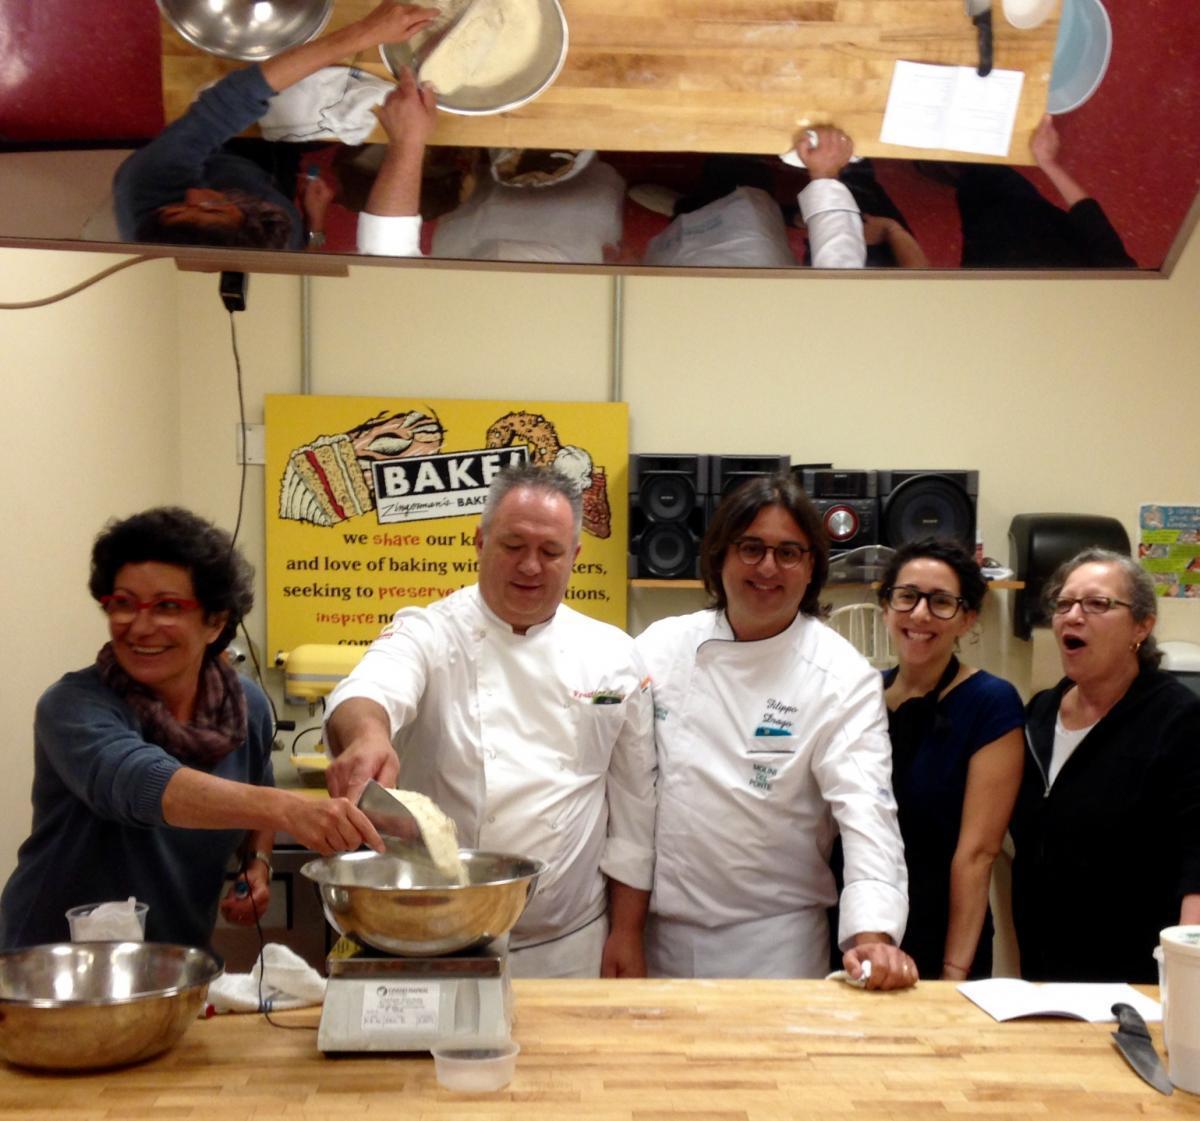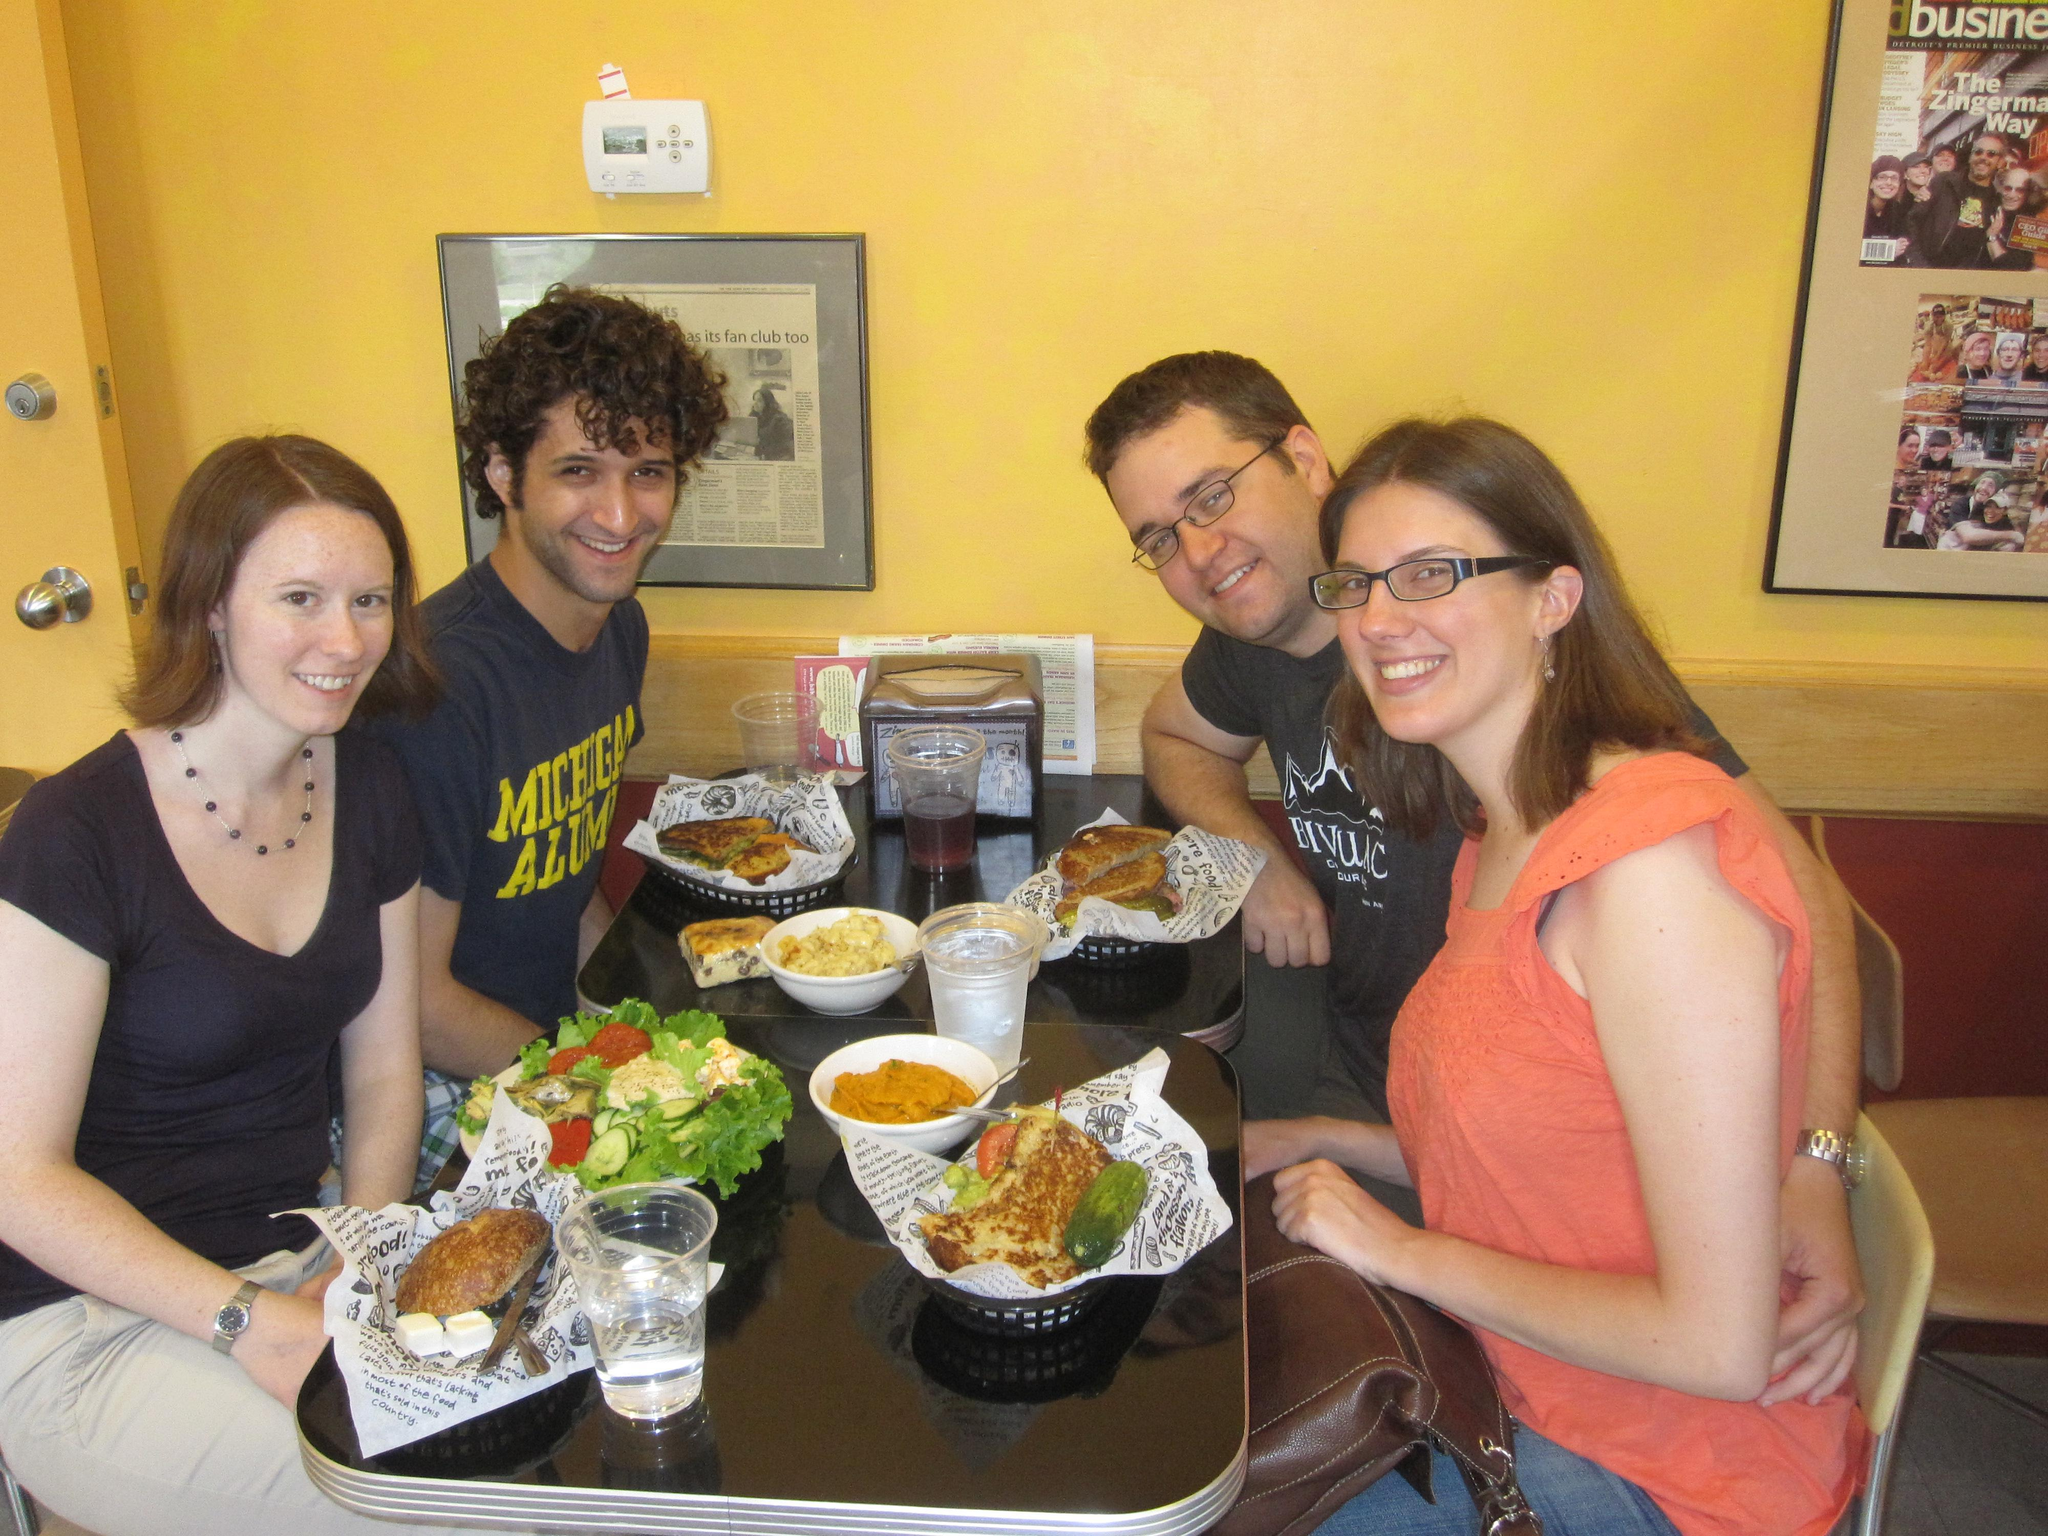The first image is the image on the left, the second image is the image on the right. Considering the images on both sides, is "There are exactly two people in the left image." valid? Answer yes or no. No. The first image is the image on the left, the second image is the image on the right. Given the left and right images, does the statement "The rack of bread in one image is flanked by two people in aprons." hold true? Answer yes or no. No. 